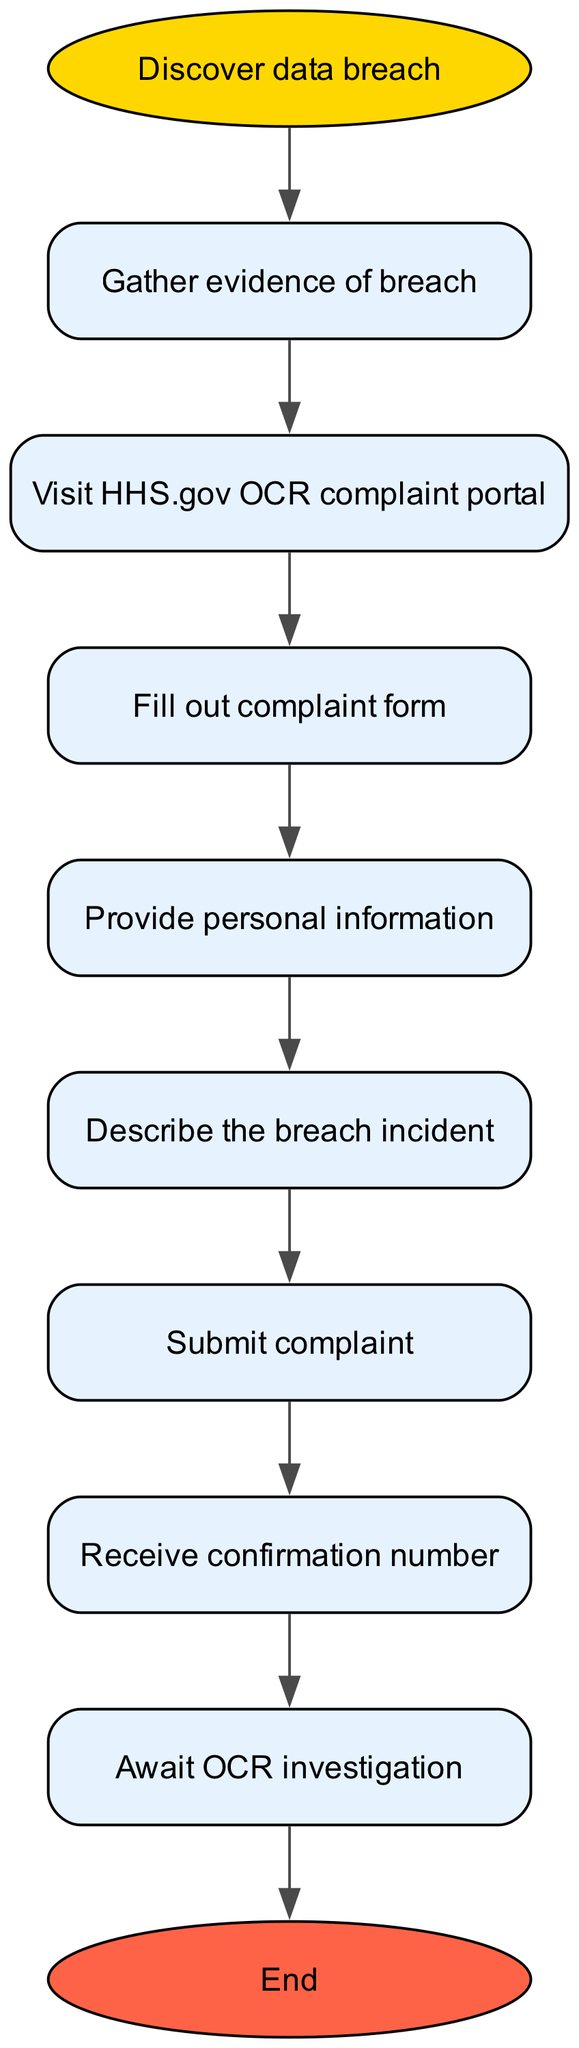What is the first step in the procedure? The diagram starts with the node labeled "Discover data breach," which indicates this is the initial action to take in the process.
Answer: Discover data breach How many steps are there in the procedure? Counting all the individual steps listed from gathering evidence to awaiting the investigation, there are a total of eight steps in the diagram.
Answer: 8 What do you need to do after filling out the complaint form? The flow chart indicates that once the complaint form is filled out, the next step is to “Provide personal information."
Answer: Provide personal information What is the final action in the procedure? According to the diagram, the last step, which signifies the end of the process, is “Await OCR investigation.” This is the last action to be taken after submitting the complaint.
Answer: Await OCR investigation What comes after gathering evidence of a breach? After gathering evidence, the next action is to “Visit HHS.gov OCR complaint portal,” which leads to filing the complaint.
Answer: Visit HHS.gov OCR complaint portal What is the confirmation received after submitting the complaint? The diagram shows that after submitting the complaint, the next node is “Receive confirmation number,” indicating that this is the immediate follow-up action.
Answer: Receive confirmation number What happens if the complaint is not submitted? The diagram does not directly illustrate consequences for not submitting the complaint; however, it can be inferred that if the submit complaint step is skipped, the process cannot proceed to receive confirmation or await investigation. As such, skip to that step means you do not receive confirmation.
Answer: N/A How many edges are there leading from the start node? The start node labeled “Discover data breach” has one outgoing edge that leads to the next step, which is gathering evidence of the breach. Hence, there is one edge leading from the start node.
Answer: 1 What is required to describe the incident? In the flow of the procedure, after providing personal information, you are required to “Describe the breach incident” as the next logical step in the complaint filing process.
Answer: Describe the breach incident 